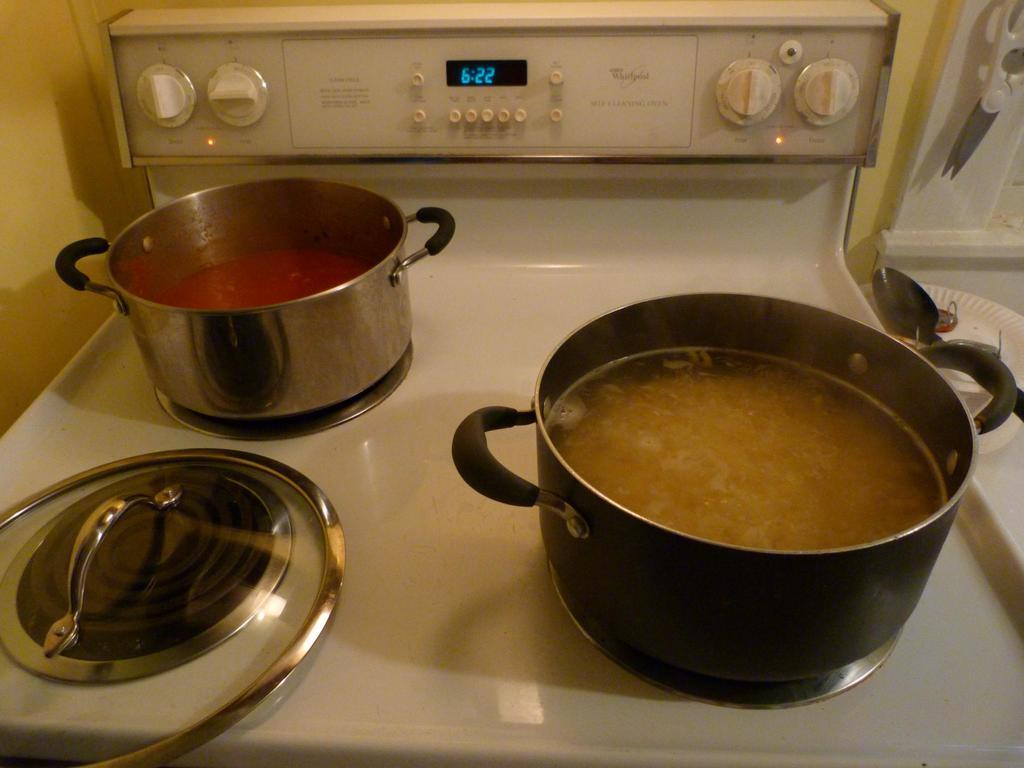Provide a one-sentence caption for the provided image. Pots filled with different sauces sit on a stove as the clock shows the time as 6:22. 